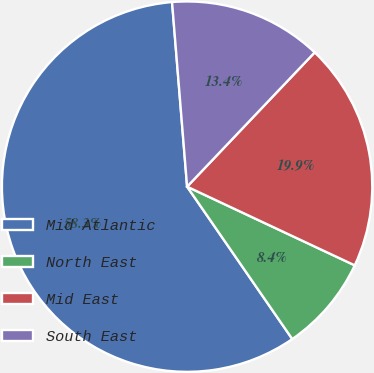Convert chart to OTSL. <chart><loc_0><loc_0><loc_500><loc_500><pie_chart><fcel>Mid Atlantic<fcel>North East<fcel>Mid East<fcel>South East<nl><fcel>58.32%<fcel>8.4%<fcel>19.89%<fcel>13.39%<nl></chart> 